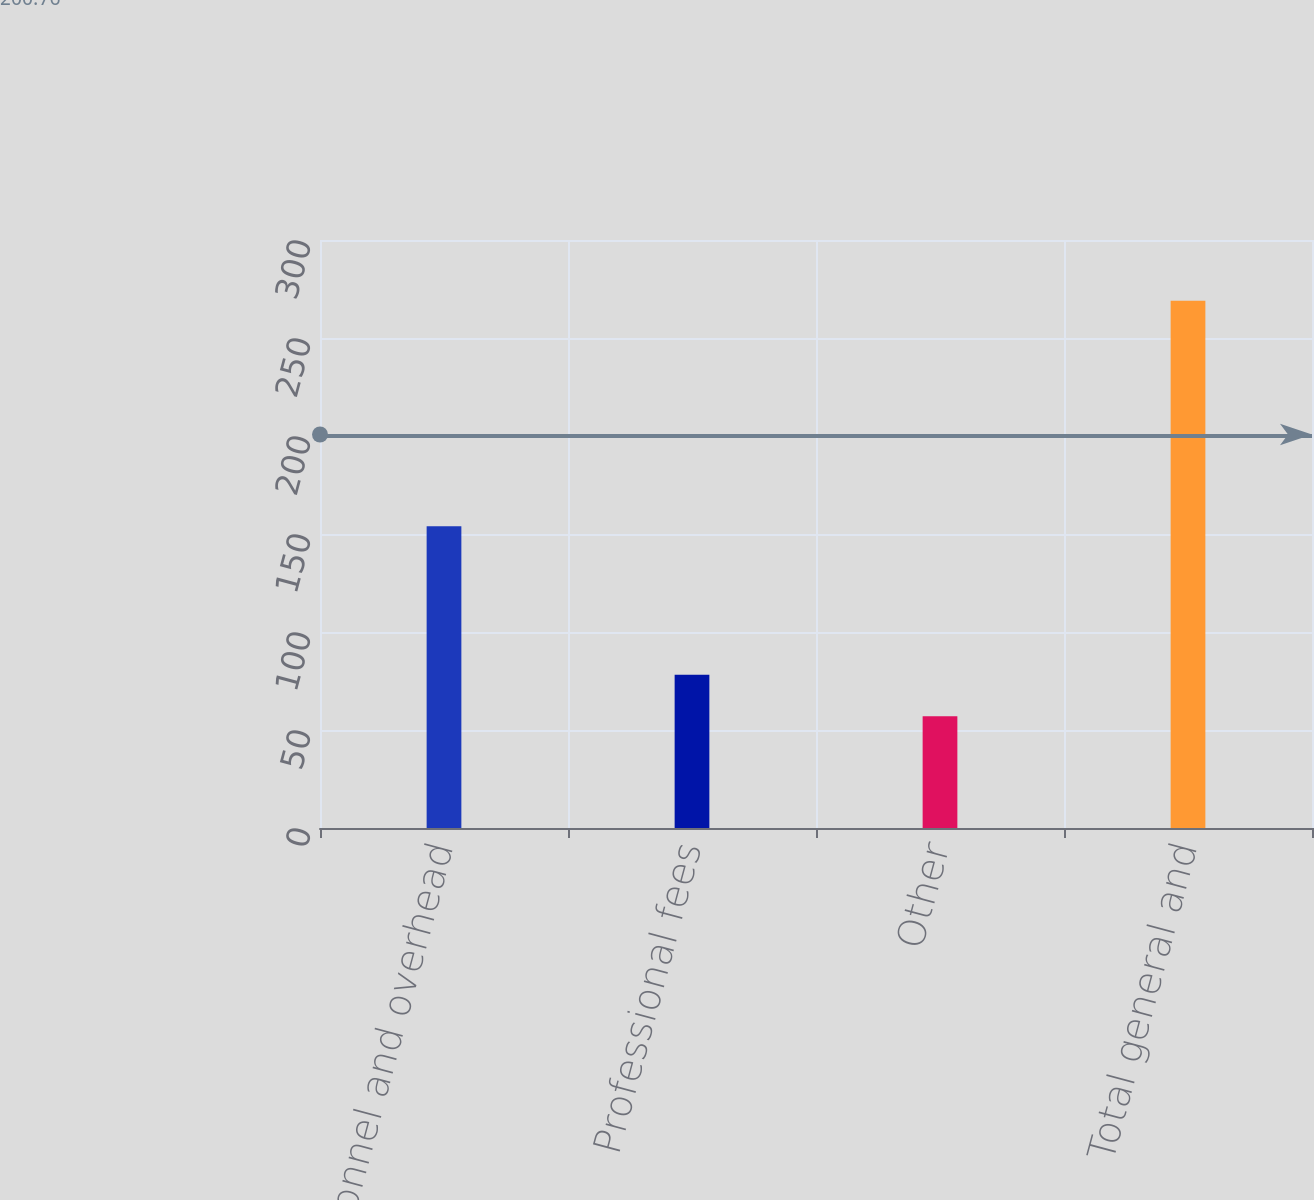Convert chart. <chart><loc_0><loc_0><loc_500><loc_500><bar_chart><fcel>Personnel and overhead<fcel>Professional fees<fcel>Other<fcel>Total general and<nl><fcel>154<fcel>78.2<fcel>57<fcel>269<nl></chart> 